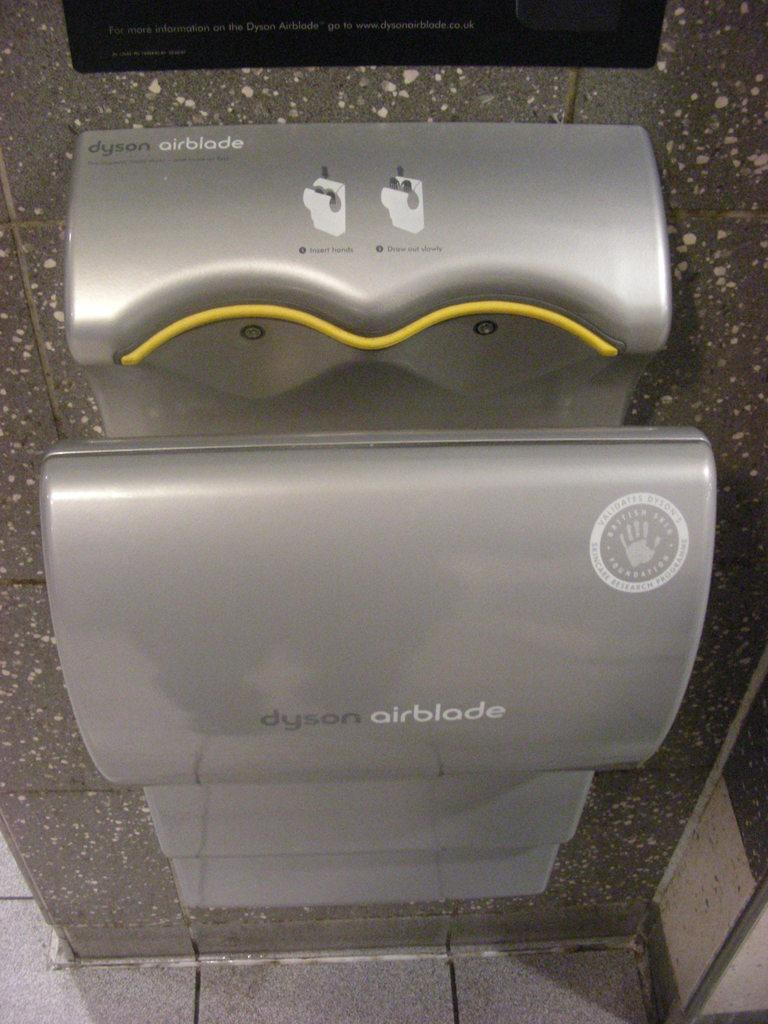Provide a one-sentence caption for the provided image. A dyson airblade touchless hand dryer hanging on a wall. 